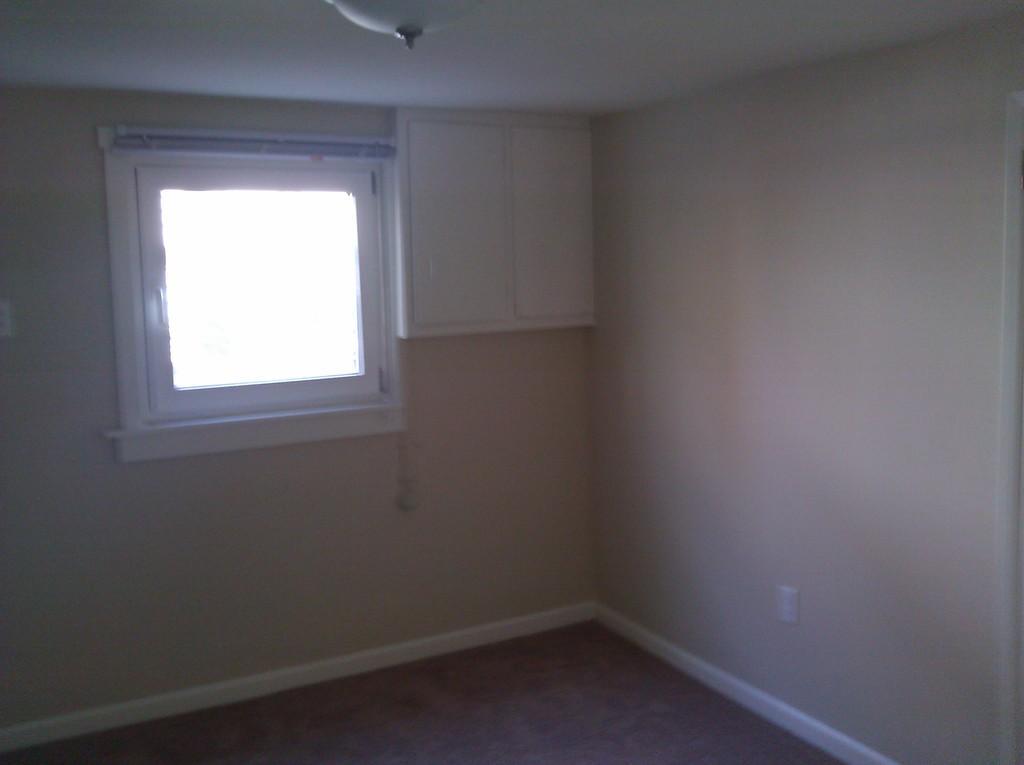Can you describe this image briefly? This picture is clicked inside the room. At the bottom, we see the floor. On the right side, we see a white wall. In the background, we see a window and a cupboard in white color. At the top, we see a white color object and a wall in white color. 